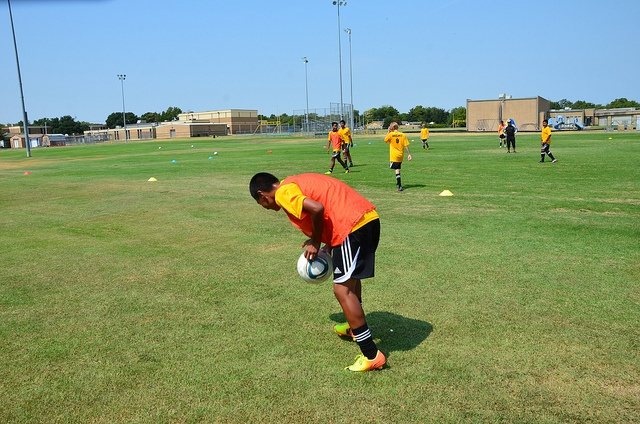Describe the objects in this image and their specific colors. I can see people in gray, black, salmon, maroon, and gold tones, people in gray, orange, gold, black, and olive tones, sports ball in gray, white, black, and darkgray tones, people in gray, black, salmon, maroon, and orange tones, and people in gray, black, green, maroon, and orange tones in this image. 